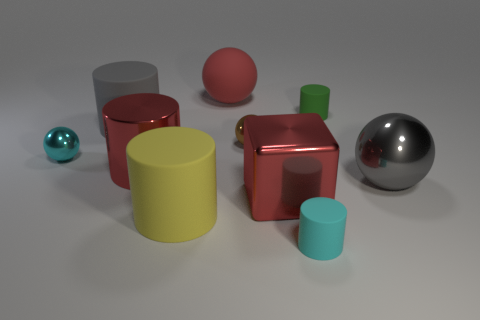Subtract 1 cylinders. How many cylinders are left? 4 Subtract all gray cylinders. How many cylinders are left? 4 Subtract all red cylinders. How many cylinders are left? 4 Subtract all brown cylinders. Subtract all brown blocks. How many cylinders are left? 5 Subtract all cubes. How many objects are left? 9 Add 5 green rubber objects. How many green rubber objects exist? 6 Subtract 0 purple balls. How many objects are left? 10 Subtract all tiny brown shiny cylinders. Subtract all matte spheres. How many objects are left? 9 Add 3 blocks. How many blocks are left? 4 